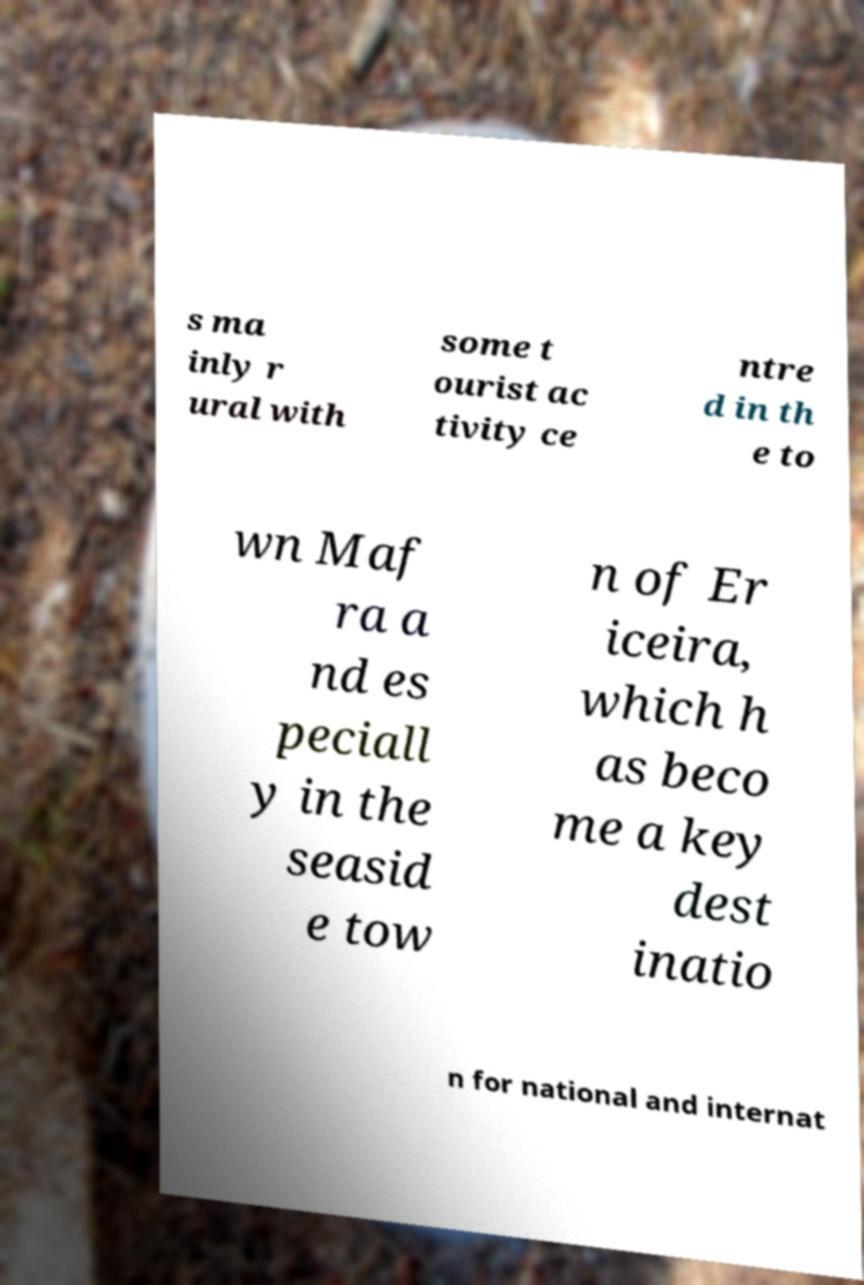Please read and relay the text visible in this image. What does it say? s ma inly r ural with some t ourist ac tivity ce ntre d in th e to wn Maf ra a nd es peciall y in the seasid e tow n of Er iceira, which h as beco me a key dest inatio n for national and internat 